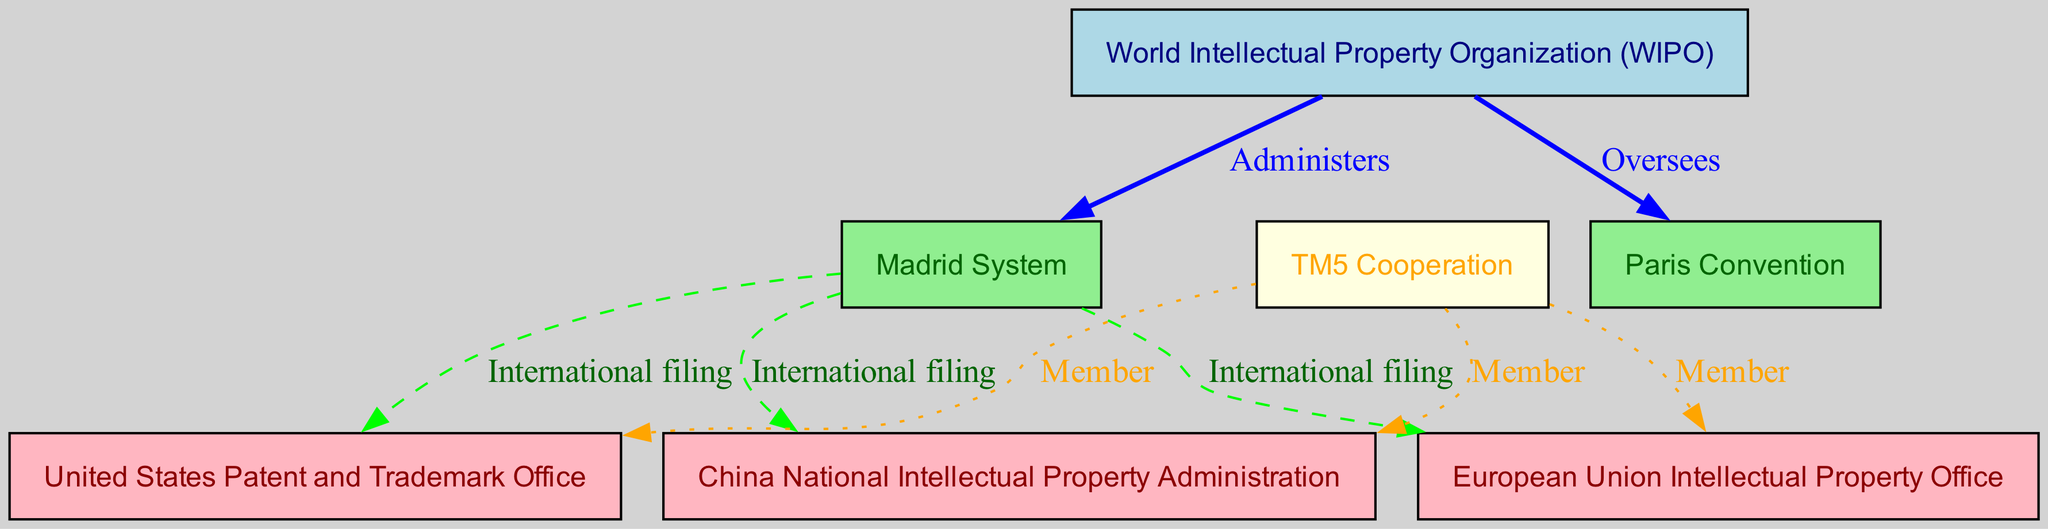What organization administers the Madrid System? According to the diagram, the edge connected from WIPO to Madrid is labeled "Administers." This indicates that the World Intellectual Property Organization (WIPO) is responsible for the administration of the Madrid System.
Answer: World Intellectual Property Organization (WIPO) How many international filing routes are depicted in the diagram? The diagram shows three edges from the Madrid node to the USPTO, EUIPO, and CNIPA nodes, each labeled "International filing." Therefore, there are three distinct international filing routes represented in the diagram.
Answer: 3 What is the relationship between WIPO and the Paris Convention? The diagram shows an edge from WIPO to Paris labeled "Oversees." This means that the World Intellectual Property Organization (WIPO) is overseeing the Paris Convention.
Answer: Oversees Which offices are members of TM5 Cooperation? The diagram has three edges leading from the TM5 node to the USPTO, EUIPO, and CNIPA nodes, each labeled "Member." This indicates that the United States Patent and Trademark Office, European Union Intellectual Property Office, and China National Intellectual Property Administration are all members of TM5 Cooperation.
Answer: United States Patent and Trademark Office, European Union Intellectual Property Office, China National Intellectual Property Administration What color represents the nodes under the Madrid System in the diagram? In the diagram, the nodes representing the Madrid System are depicted in light green, which corresponds to the color assigned to the Madrid node. Therefore, all nodes under the Madrid System share this color.
Answer: Light green How do the relationships between TM5 and the trademark offices differ from the relationships involving WIPO? The relationships involving TM5 are indicated as "Member" and are represented by dotted edges, while WIPO's relationships with other nodes involve administering and overseeing with solid edges. This highlights that TM5 is a collaborative membership basis, while WIPO has governance roles.
Answer: Membership vs. Governance Which office is overseen by WIPO in terms of international trademark agreements? The diagram shows an edge from WIPO to Paris labeled "Oversees." This indicates that among the offices, the Paris Convention is under the oversight of WIPO in terms of international trademark agreements.
Answer: Paris Convention What style is used for the edges representing international filing? The edges representing international filing, which connect the Madrid node to the USPTO, EUIPO, and CNIPA, are styled as dashed lines in the diagram. This stylistic choice differentiates them from other types of relationships in the network.
Answer: Dashed lines Which office is highlighted in light yellow within the diagram? The only node depicted in light yellow is the TM5 node. This color designation is unique to the TM5 Cooperation, distinguishing it from other offices represented in the diagram.
Answer: TM5 